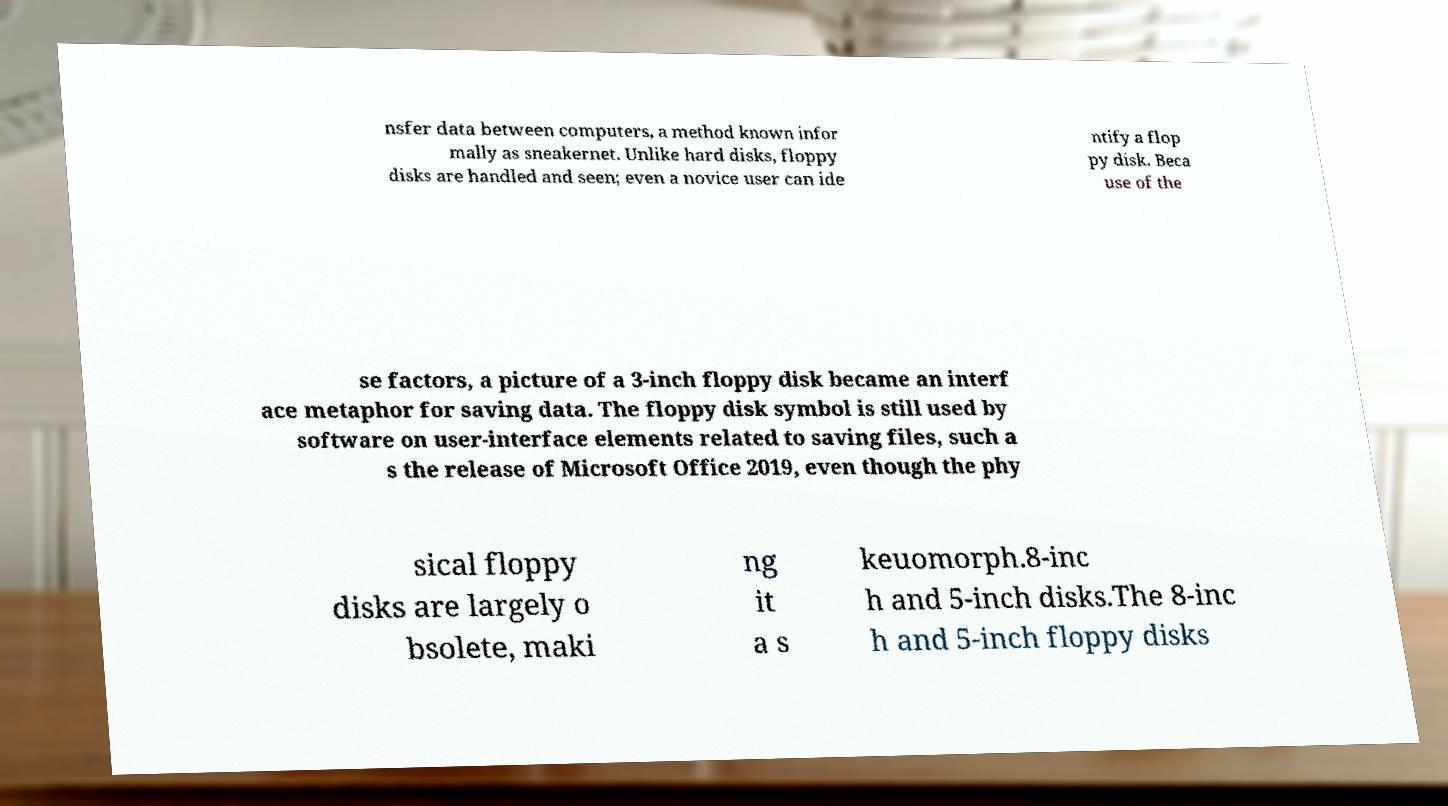For documentation purposes, I need the text within this image transcribed. Could you provide that? nsfer data between computers, a method known infor mally as sneakernet. Unlike hard disks, floppy disks are handled and seen; even a novice user can ide ntify a flop py disk. Beca use of the se factors, a picture of a 3-inch floppy disk became an interf ace metaphor for saving data. The floppy disk symbol is still used by software on user-interface elements related to saving files, such a s the release of Microsoft Office 2019, even though the phy sical floppy disks are largely o bsolete, maki ng it a s keuomorph.8-inc h and 5-inch disks.The 8-inc h and 5-inch floppy disks 